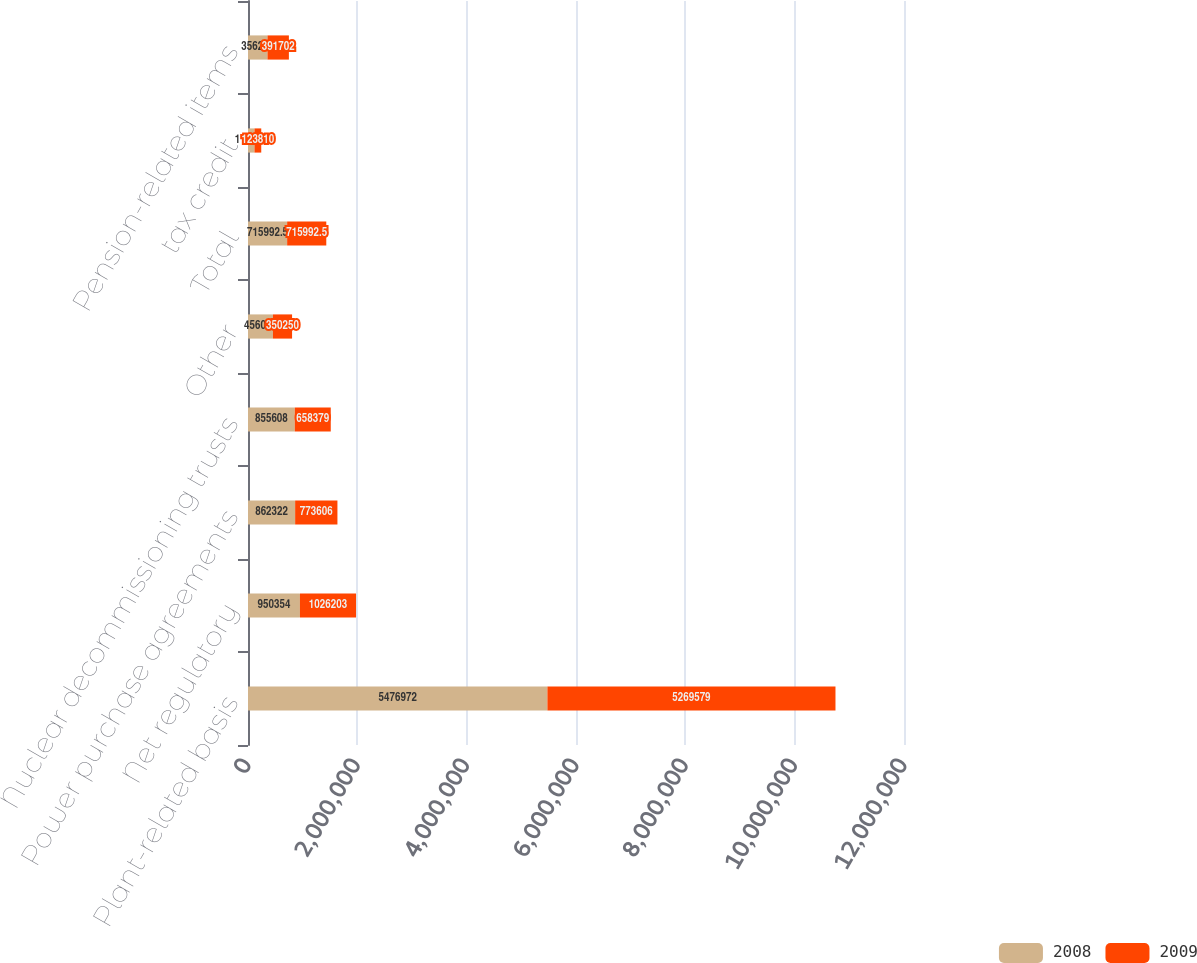<chart> <loc_0><loc_0><loc_500><loc_500><stacked_bar_chart><ecel><fcel>Plant-related basis<fcel>Net regulatory<fcel>Power purchase agreements<fcel>Nuclear decommissioning trusts<fcel>Other<fcel>Total<fcel>tax credit<fcel>Pension-related items<nl><fcel>2008<fcel>5.47697e+06<fcel>950354<fcel>862322<fcel>855608<fcel>456053<fcel>715992<fcel>118587<fcel>356284<nl><fcel>2009<fcel>5.26958e+06<fcel>1.0262e+06<fcel>773606<fcel>658379<fcel>350250<fcel>715992<fcel>123810<fcel>391702<nl></chart> 